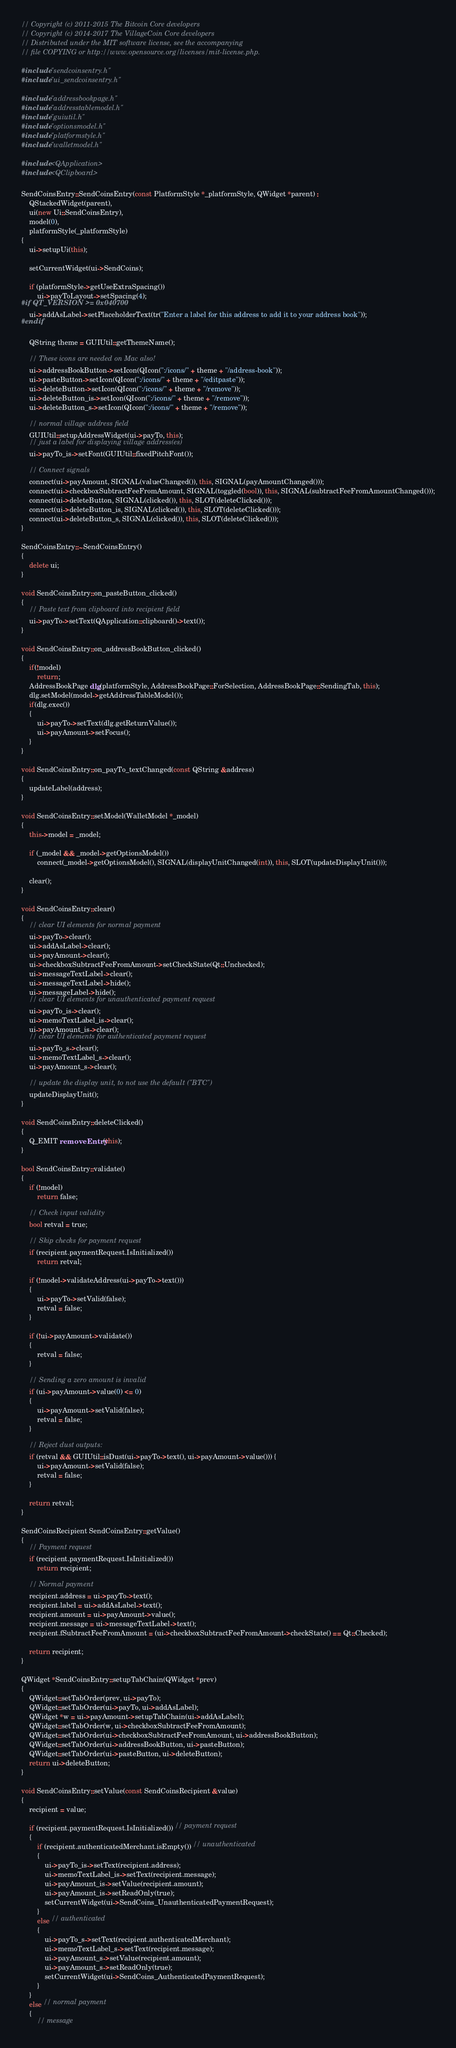Convert code to text. <code><loc_0><loc_0><loc_500><loc_500><_C++_>// Copyright (c) 2011-2015 The Bitcoin Core developers
// Copyright (c) 2014-2017 The VillageCoin Core developers
// Distributed under the MIT software license, see the accompanying
// file COPYING or http://www.opensource.org/licenses/mit-license.php.

#include "sendcoinsentry.h"
#include "ui_sendcoinsentry.h"

#include "addressbookpage.h"
#include "addresstablemodel.h"
#include "guiutil.h"
#include "optionsmodel.h"
#include "platformstyle.h"
#include "walletmodel.h"

#include <QApplication>
#include <QClipboard>

SendCoinsEntry::SendCoinsEntry(const PlatformStyle *_platformStyle, QWidget *parent) :
    QStackedWidget(parent),
    ui(new Ui::SendCoinsEntry),
    model(0),
    platformStyle(_platformStyle)
{
    ui->setupUi(this);

    setCurrentWidget(ui->SendCoins);

    if (platformStyle->getUseExtraSpacing())
        ui->payToLayout->setSpacing(4);
#if QT_VERSION >= 0x040700
    ui->addAsLabel->setPlaceholderText(tr("Enter a label for this address to add it to your address book"));
#endif

    QString theme = GUIUtil::getThemeName();

    // These icons are needed on Mac also!
    ui->addressBookButton->setIcon(QIcon(":/icons/" + theme + "/address-book"));
    ui->pasteButton->setIcon(QIcon(":/icons/" + theme + "/editpaste"));
    ui->deleteButton->setIcon(QIcon(":/icons/" + theme + "/remove"));
    ui->deleteButton_is->setIcon(QIcon(":/icons/" + theme + "/remove"));
    ui->deleteButton_s->setIcon(QIcon(":/icons/" + theme + "/remove"));
      
    // normal village address field
    GUIUtil::setupAddressWidget(ui->payTo, this);
    // just a label for displaying village address(es)
    ui->payTo_is->setFont(GUIUtil::fixedPitchFont());

    // Connect signals
    connect(ui->payAmount, SIGNAL(valueChanged()), this, SIGNAL(payAmountChanged()));
    connect(ui->checkboxSubtractFeeFromAmount, SIGNAL(toggled(bool)), this, SIGNAL(subtractFeeFromAmountChanged()));
    connect(ui->deleteButton, SIGNAL(clicked()), this, SLOT(deleteClicked()));
    connect(ui->deleteButton_is, SIGNAL(clicked()), this, SLOT(deleteClicked()));
    connect(ui->deleteButton_s, SIGNAL(clicked()), this, SLOT(deleteClicked()));
}

SendCoinsEntry::~SendCoinsEntry()
{
    delete ui;
}

void SendCoinsEntry::on_pasteButton_clicked()
{
    // Paste text from clipboard into recipient field
    ui->payTo->setText(QApplication::clipboard()->text());
}

void SendCoinsEntry::on_addressBookButton_clicked()
{
    if(!model)
        return;
    AddressBookPage dlg(platformStyle, AddressBookPage::ForSelection, AddressBookPage::SendingTab, this);
    dlg.setModel(model->getAddressTableModel());
    if(dlg.exec())
    {
        ui->payTo->setText(dlg.getReturnValue());
        ui->payAmount->setFocus();
    }
}

void SendCoinsEntry::on_payTo_textChanged(const QString &address)
{
    updateLabel(address);
}

void SendCoinsEntry::setModel(WalletModel *_model)
{
    this->model = _model;

    if (_model && _model->getOptionsModel())
        connect(_model->getOptionsModel(), SIGNAL(displayUnitChanged(int)), this, SLOT(updateDisplayUnit()));

    clear();
}

void SendCoinsEntry::clear()
{
    // clear UI elements for normal payment
    ui->payTo->clear();
    ui->addAsLabel->clear();
    ui->payAmount->clear();
    ui->checkboxSubtractFeeFromAmount->setCheckState(Qt::Unchecked);
    ui->messageTextLabel->clear();
    ui->messageTextLabel->hide();
    ui->messageLabel->hide();
    // clear UI elements for unauthenticated payment request
    ui->payTo_is->clear();
    ui->memoTextLabel_is->clear();
    ui->payAmount_is->clear();
    // clear UI elements for authenticated payment request
    ui->payTo_s->clear();
    ui->memoTextLabel_s->clear();
    ui->payAmount_s->clear();

    // update the display unit, to not use the default ("BTC")
    updateDisplayUnit();
}

void SendCoinsEntry::deleteClicked()
{
    Q_EMIT removeEntry(this);
}

bool SendCoinsEntry::validate()
{
    if (!model)
        return false;

    // Check input validity
    bool retval = true;

    // Skip checks for payment request
    if (recipient.paymentRequest.IsInitialized())
        return retval;

    if (!model->validateAddress(ui->payTo->text()))
    {
        ui->payTo->setValid(false);
        retval = false;
    }

    if (!ui->payAmount->validate())
    {
        retval = false;
    }

    // Sending a zero amount is invalid
    if (ui->payAmount->value(0) <= 0)
    {
        ui->payAmount->setValid(false);
        retval = false;
    }

    // Reject dust outputs:
    if (retval && GUIUtil::isDust(ui->payTo->text(), ui->payAmount->value())) {
        ui->payAmount->setValid(false);
        retval = false;
    }

    return retval;
}

SendCoinsRecipient SendCoinsEntry::getValue()
{
    // Payment request
    if (recipient.paymentRequest.IsInitialized())
        return recipient;

    // Normal payment
    recipient.address = ui->payTo->text();
    recipient.label = ui->addAsLabel->text();
    recipient.amount = ui->payAmount->value();
    recipient.message = ui->messageTextLabel->text();
    recipient.fSubtractFeeFromAmount = (ui->checkboxSubtractFeeFromAmount->checkState() == Qt::Checked);

    return recipient;
}

QWidget *SendCoinsEntry::setupTabChain(QWidget *prev)
{
    QWidget::setTabOrder(prev, ui->payTo);
    QWidget::setTabOrder(ui->payTo, ui->addAsLabel);
    QWidget *w = ui->payAmount->setupTabChain(ui->addAsLabel);
    QWidget::setTabOrder(w, ui->checkboxSubtractFeeFromAmount);
    QWidget::setTabOrder(ui->checkboxSubtractFeeFromAmount, ui->addressBookButton);
    QWidget::setTabOrder(ui->addressBookButton, ui->pasteButton);
    QWidget::setTabOrder(ui->pasteButton, ui->deleteButton);
    return ui->deleteButton;
}

void SendCoinsEntry::setValue(const SendCoinsRecipient &value)
{
    recipient = value;

    if (recipient.paymentRequest.IsInitialized()) // payment request
    {
        if (recipient.authenticatedMerchant.isEmpty()) // unauthenticated
        {
            ui->payTo_is->setText(recipient.address);
            ui->memoTextLabel_is->setText(recipient.message);
            ui->payAmount_is->setValue(recipient.amount);
            ui->payAmount_is->setReadOnly(true);
            setCurrentWidget(ui->SendCoins_UnauthenticatedPaymentRequest);
        }
        else // authenticated
        {
            ui->payTo_s->setText(recipient.authenticatedMerchant);
            ui->memoTextLabel_s->setText(recipient.message);
            ui->payAmount_s->setValue(recipient.amount);
            ui->payAmount_s->setReadOnly(true);
            setCurrentWidget(ui->SendCoins_AuthenticatedPaymentRequest);
        }
    }
    else // normal payment
    {
        // message</code> 